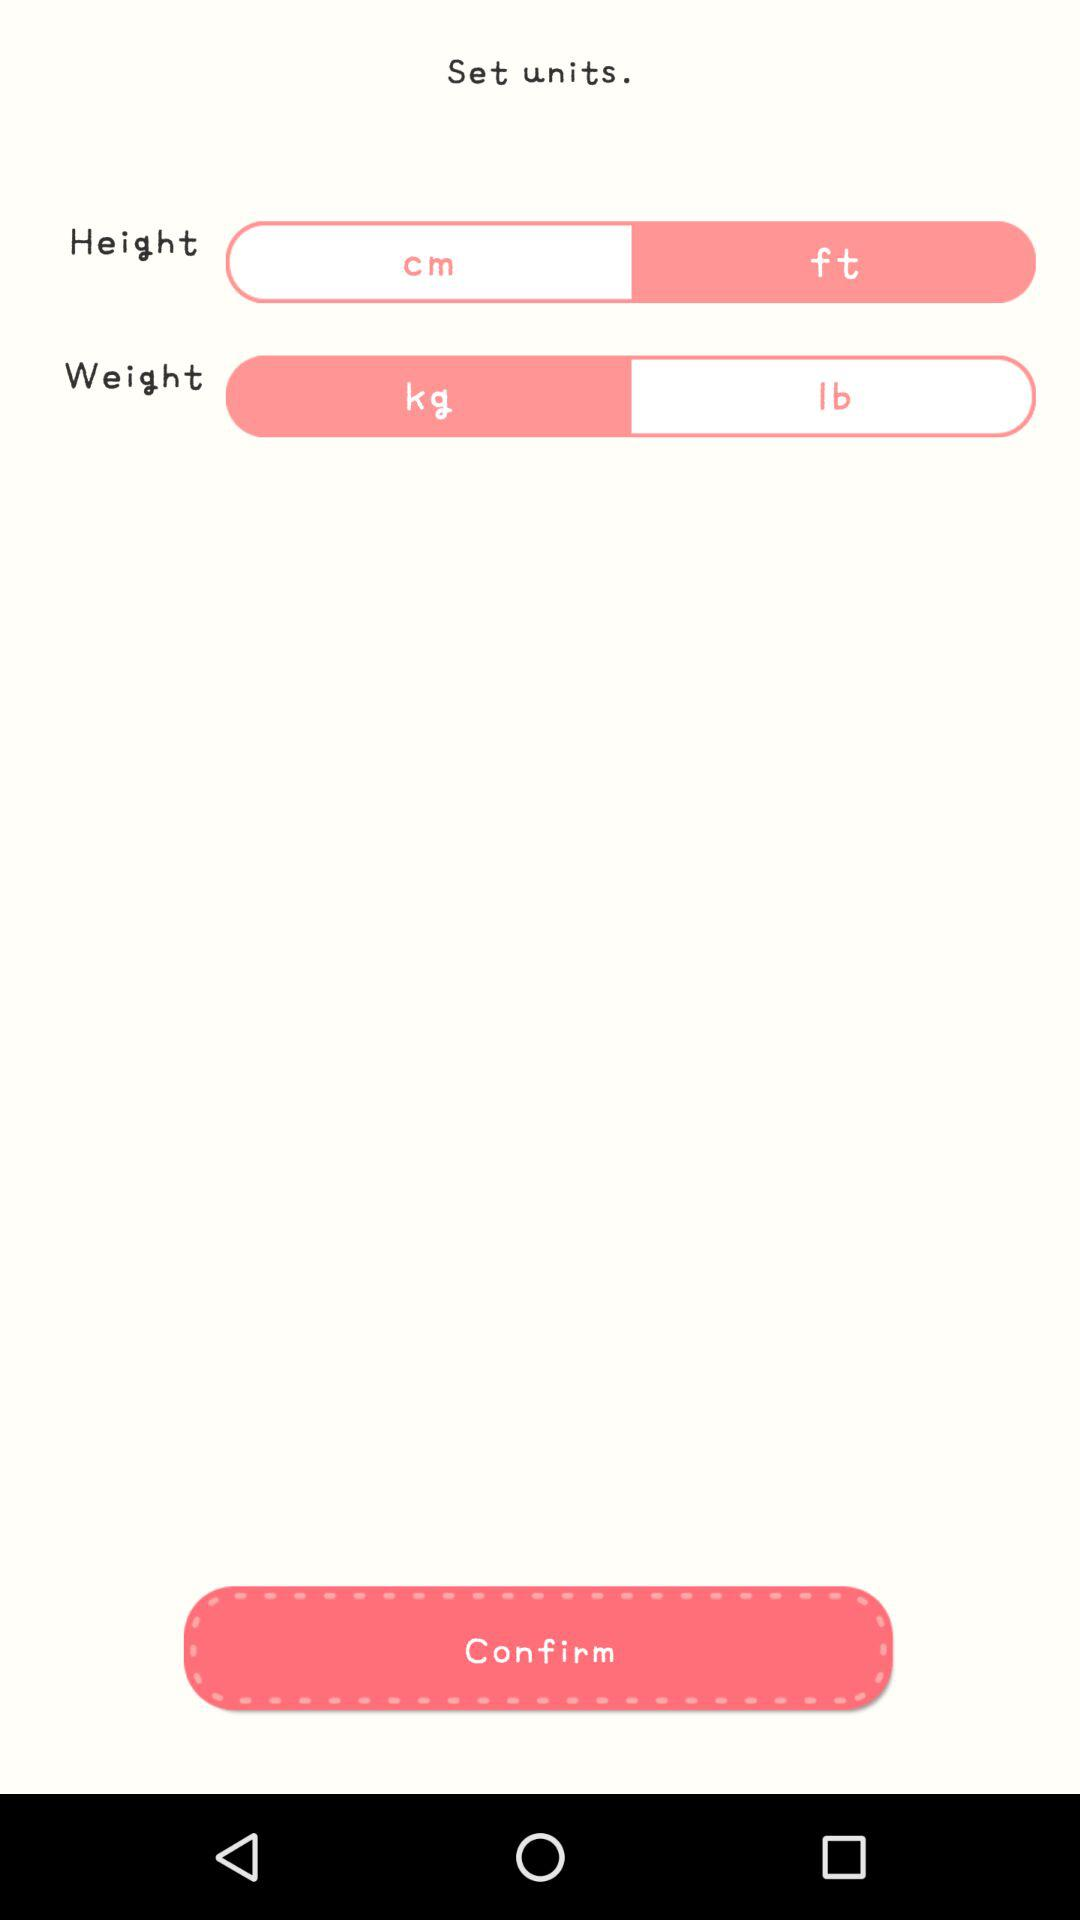What is the unit of weight? The unit of weight is kg. 